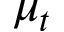<formula> <loc_0><loc_0><loc_500><loc_500>\mu _ { t }</formula> 